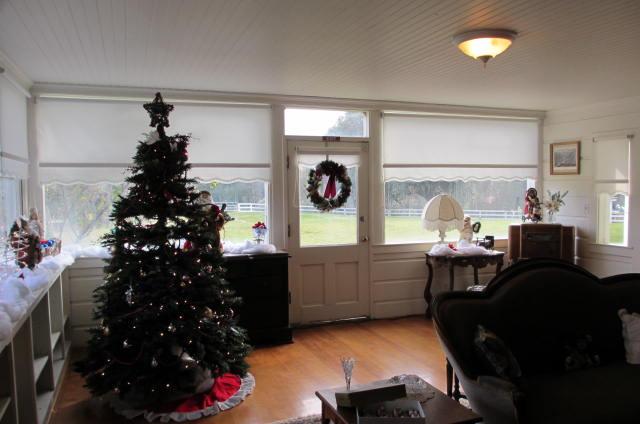What type of flooring is in the room?
Be succinct. Wood. Is it Christmas?
Write a very short answer. Yes. Is it daytime?
Answer briefly. Yes. 